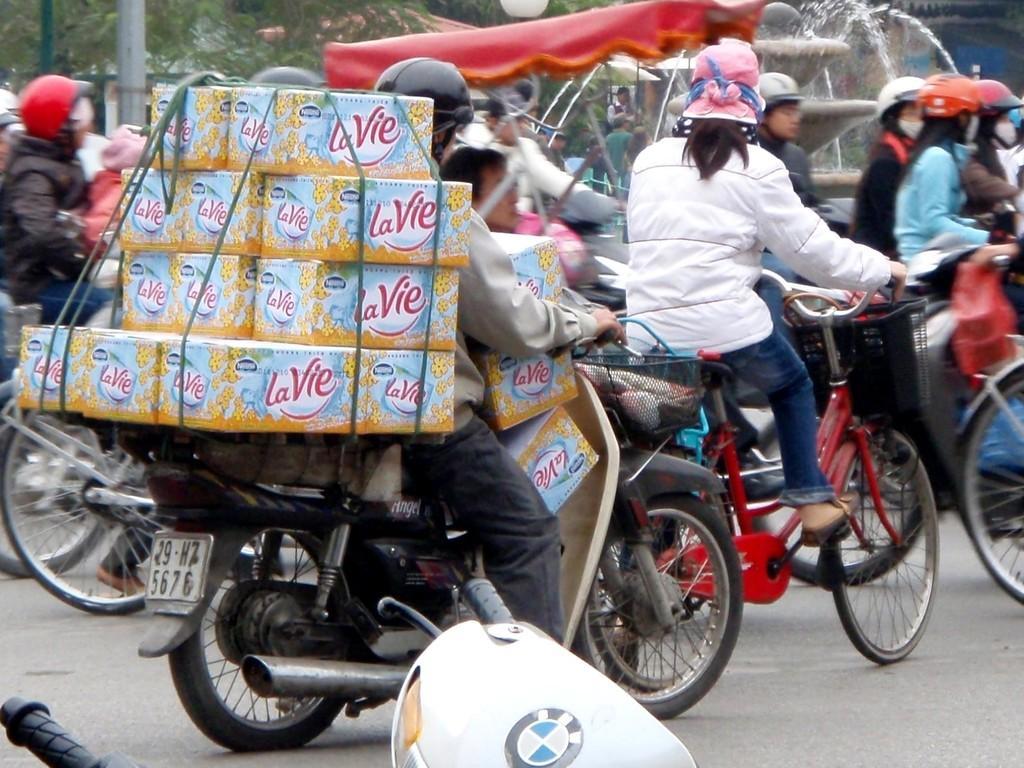Can you describe this image briefly? In this picture we can see a person riding a motorcycle with huge luggage, behind the motorcycle there is a bicycle and a woman riding it, in the background group of people riding their own bicycles and all of them are wearing helmets, we can see a water fountain in the background and also we can see trees and one pole in the background. 